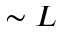<formula> <loc_0><loc_0><loc_500><loc_500>\sim L</formula> 